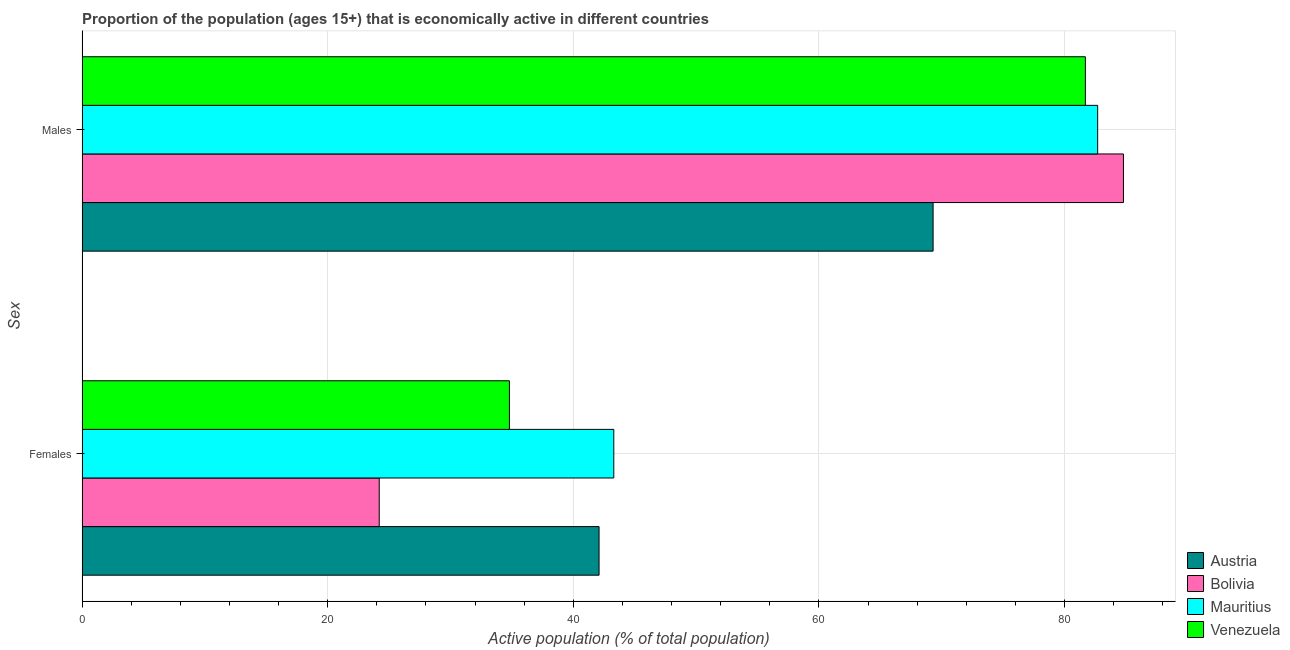How many groups of bars are there?
Your response must be concise. 2. How many bars are there on the 2nd tick from the top?
Ensure brevity in your answer.  4. How many bars are there on the 2nd tick from the bottom?
Ensure brevity in your answer.  4. What is the label of the 2nd group of bars from the top?
Give a very brief answer. Females. What is the percentage of economically active male population in Venezuela?
Offer a very short reply. 81.7. Across all countries, what is the maximum percentage of economically active male population?
Offer a very short reply. 84.8. Across all countries, what is the minimum percentage of economically active female population?
Give a very brief answer. 24.2. In which country was the percentage of economically active female population maximum?
Your response must be concise. Mauritius. In which country was the percentage of economically active male population minimum?
Provide a succinct answer. Austria. What is the total percentage of economically active female population in the graph?
Your answer should be compact. 144.4. What is the difference between the percentage of economically active male population in Mauritius and that in Austria?
Your answer should be compact. 13.4. What is the difference between the percentage of economically active female population in Mauritius and the percentage of economically active male population in Austria?
Give a very brief answer. -26. What is the average percentage of economically active male population per country?
Provide a short and direct response. 79.62. What is the difference between the percentage of economically active female population and percentage of economically active male population in Austria?
Make the answer very short. -27.2. In how many countries, is the percentage of economically active female population greater than 84 %?
Your response must be concise. 0. What is the ratio of the percentage of economically active female population in Venezuela to that in Austria?
Your response must be concise. 0.83. Is the percentage of economically active female population in Austria less than that in Venezuela?
Your answer should be very brief. No. What does the 3rd bar from the top in Males represents?
Give a very brief answer. Bolivia. What does the 4th bar from the bottom in Males represents?
Offer a very short reply. Venezuela. Are all the bars in the graph horizontal?
Offer a terse response. Yes. Does the graph contain grids?
Ensure brevity in your answer.  Yes. How many legend labels are there?
Keep it short and to the point. 4. What is the title of the graph?
Provide a succinct answer. Proportion of the population (ages 15+) that is economically active in different countries. Does "Brunei Darussalam" appear as one of the legend labels in the graph?
Your response must be concise. No. What is the label or title of the X-axis?
Give a very brief answer. Active population (% of total population). What is the label or title of the Y-axis?
Give a very brief answer. Sex. What is the Active population (% of total population) in Austria in Females?
Offer a very short reply. 42.1. What is the Active population (% of total population) of Bolivia in Females?
Provide a short and direct response. 24.2. What is the Active population (% of total population) in Mauritius in Females?
Give a very brief answer. 43.3. What is the Active population (% of total population) in Venezuela in Females?
Offer a terse response. 34.8. What is the Active population (% of total population) in Austria in Males?
Make the answer very short. 69.3. What is the Active population (% of total population) of Bolivia in Males?
Offer a very short reply. 84.8. What is the Active population (% of total population) of Mauritius in Males?
Ensure brevity in your answer.  82.7. What is the Active population (% of total population) in Venezuela in Males?
Give a very brief answer. 81.7. Across all Sex, what is the maximum Active population (% of total population) of Austria?
Provide a succinct answer. 69.3. Across all Sex, what is the maximum Active population (% of total population) of Bolivia?
Ensure brevity in your answer.  84.8. Across all Sex, what is the maximum Active population (% of total population) of Mauritius?
Provide a succinct answer. 82.7. Across all Sex, what is the maximum Active population (% of total population) in Venezuela?
Give a very brief answer. 81.7. Across all Sex, what is the minimum Active population (% of total population) in Austria?
Provide a succinct answer. 42.1. Across all Sex, what is the minimum Active population (% of total population) of Bolivia?
Provide a short and direct response. 24.2. Across all Sex, what is the minimum Active population (% of total population) in Mauritius?
Keep it short and to the point. 43.3. Across all Sex, what is the minimum Active population (% of total population) of Venezuela?
Your answer should be compact. 34.8. What is the total Active population (% of total population) in Austria in the graph?
Your answer should be compact. 111.4. What is the total Active population (% of total population) in Bolivia in the graph?
Offer a very short reply. 109. What is the total Active population (% of total population) of Mauritius in the graph?
Your response must be concise. 126. What is the total Active population (% of total population) of Venezuela in the graph?
Your response must be concise. 116.5. What is the difference between the Active population (% of total population) in Austria in Females and that in Males?
Your response must be concise. -27.2. What is the difference between the Active population (% of total population) in Bolivia in Females and that in Males?
Provide a short and direct response. -60.6. What is the difference between the Active population (% of total population) of Mauritius in Females and that in Males?
Offer a terse response. -39.4. What is the difference between the Active population (% of total population) of Venezuela in Females and that in Males?
Offer a very short reply. -46.9. What is the difference between the Active population (% of total population) of Austria in Females and the Active population (% of total population) of Bolivia in Males?
Your answer should be compact. -42.7. What is the difference between the Active population (% of total population) in Austria in Females and the Active population (% of total population) in Mauritius in Males?
Offer a terse response. -40.6. What is the difference between the Active population (% of total population) in Austria in Females and the Active population (% of total population) in Venezuela in Males?
Give a very brief answer. -39.6. What is the difference between the Active population (% of total population) in Bolivia in Females and the Active population (% of total population) in Mauritius in Males?
Your answer should be very brief. -58.5. What is the difference between the Active population (% of total population) of Bolivia in Females and the Active population (% of total population) of Venezuela in Males?
Give a very brief answer. -57.5. What is the difference between the Active population (% of total population) in Mauritius in Females and the Active population (% of total population) in Venezuela in Males?
Provide a short and direct response. -38.4. What is the average Active population (% of total population) of Austria per Sex?
Offer a very short reply. 55.7. What is the average Active population (% of total population) in Bolivia per Sex?
Provide a short and direct response. 54.5. What is the average Active population (% of total population) of Venezuela per Sex?
Your answer should be very brief. 58.25. What is the difference between the Active population (% of total population) in Austria and Active population (% of total population) in Bolivia in Females?
Offer a very short reply. 17.9. What is the difference between the Active population (% of total population) in Bolivia and Active population (% of total population) in Mauritius in Females?
Offer a very short reply. -19.1. What is the difference between the Active population (% of total population) of Bolivia and Active population (% of total population) of Venezuela in Females?
Offer a very short reply. -10.6. What is the difference between the Active population (% of total population) of Austria and Active population (% of total population) of Bolivia in Males?
Your response must be concise. -15.5. What is the difference between the Active population (% of total population) of Bolivia and Active population (% of total population) of Mauritius in Males?
Offer a very short reply. 2.1. What is the difference between the Active population (% of total population) in Bolivia and Active population (% of total population) in Venezuela in Males?
Your response must be concise. 3.1. What is the difference between the Active population (% of total population) of Mauritius and Active population (% of total population) of Venezuela in Males?
Keep it short and to the point. 1. What is the ratio of the Active population (% of total population) of Austria in Females to that in Males?
Make the answer very short. 0.61. What is the ratio of the Active population (% of total population) in Bolivia in Females to that in Males?
Offer a terse response. 0.29. What is the ratio of the Active population (% of total population) in Mauritius in Females to that in Males?
Provide a succinct answer. 0.52. What is the ratio of the Active population (% of total population) in Venezuela in Females to that in Males?
Provide a short and direct response. 0.43. What is the difference between the highest and the second highest Active population (% of total population) in Austria?
Your response must be concise. 27.2. What is the difference between the highest and the second highest Active population (% of total population) of Bolivia?
Give a very brief answer. 60.6. What is the difference between the highest and the second highest Active population (% of total population) in Mauritius?
Offer a terse response. 39.4. What is the difference between the highest and the second highest Active population (% of total population) in Venezuela?
Your answer should be very brief. 46.9. What is the difference between the highest and the lowest Active population (% of total population) in Austria?
Make the answer very short. 27.2. What is the difference between the highest and the lowest Active population (% of total population) in Bolivia?
Provide a short and direct response. 60.6. What is the difference between the highest and the lowest Active population (% of total population) in Mauritius?
Your response must be concise. 39.4. What is the difference between the highest and the lowest Active population (% of total population) in Venezuela?
Provide a succinct answer. 46.9. 